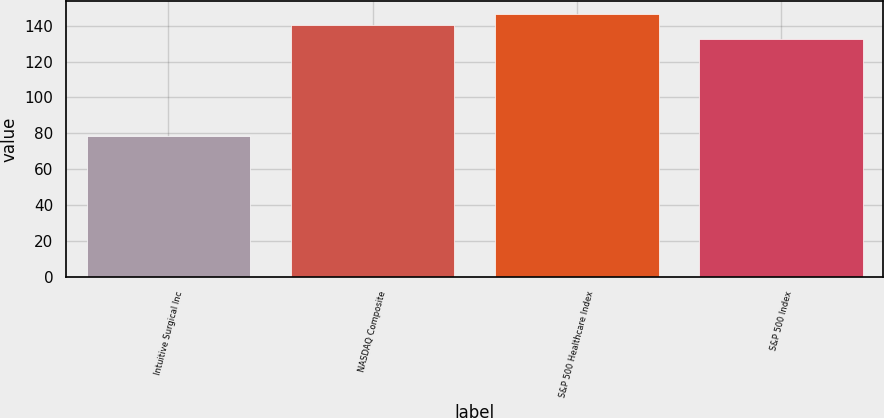Convert chart. <chart><loc_0><loc_0><loc_500><loc_500><bar_chart><fcel>Intuitive Surgical Inc<fcel>NASDAQ Composite<fcel>S&P 500 Healthcare Index<fcel>S&P 500 Index<nl><fcel>78.32<fcel>140.12<fcel>146.43<fcel>132.39<nl></chart> 